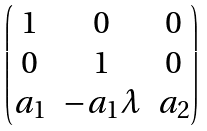<formula> <loc_0><loc_0><loc_500><loc_500>\begin{pmatrix} 1 & 0 & 0 \\ 0 & 1 & 0 \\ a _ { 1 } & - a _ { 1 } \lambda & a _ { 2 } \\ \end{pmatrix}</formula> 